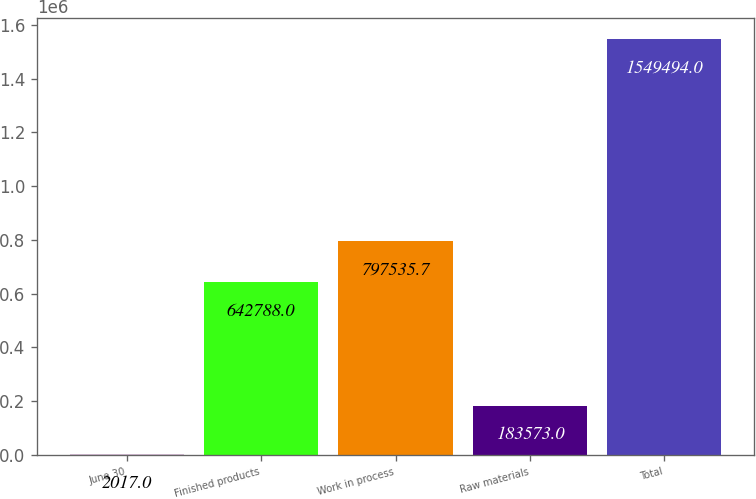<chart> <loc_0><loc_0><loc_500><loc_500><bar_chart><fcel>June 30<fcel>Finished products<fcel>Work in process<fcel>Raw materials<fcel>Total<nl><fcel>2017<fcel>642788<fcel>797536<fcel>183573<fcel>1.54949e+06<nl></chart> 